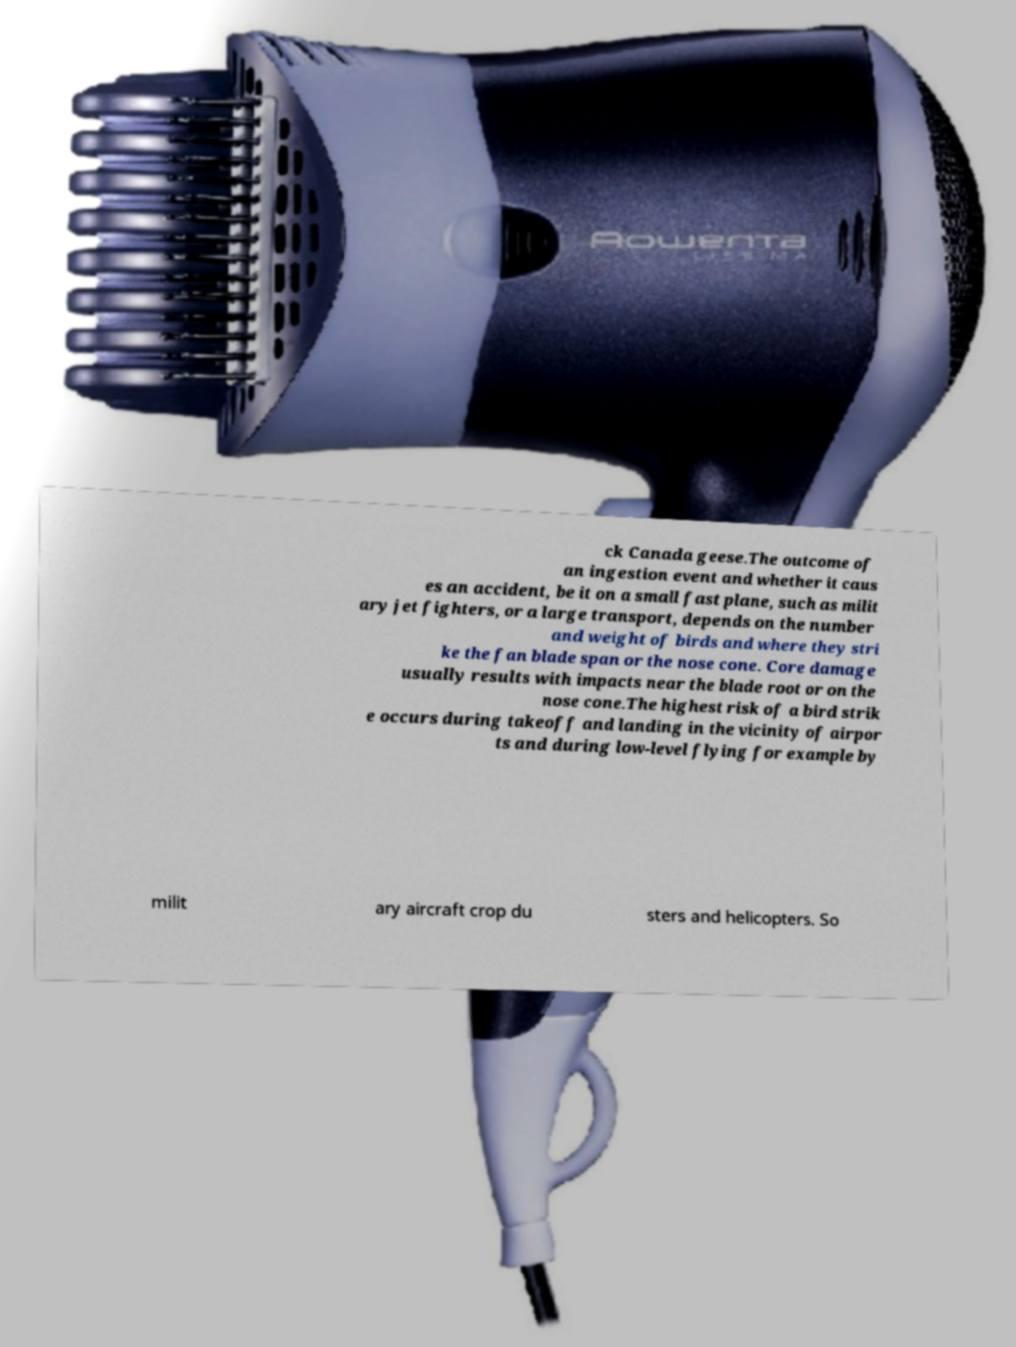Can you accurately transcribe the text from the provided image for me? ck Canada geese.The outcome of an ingestion event and whether it caus es an accident, be it on a small fast plane, such as milit ary jet fighters, or a large transport, depends on the number and weight of birds and where they stri ke the fan blade span or the nose cone. Core damage usually results with impacts near the blade root or on the nose cone.The highest risk of a bird strik e occurs during takeoff and landing in the vicinity of airpor ts and during low-level flying for example by milit ary aircraft crop du sters and helicopters. So 